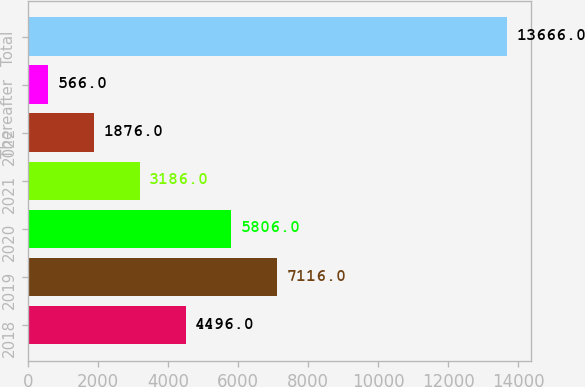Convert chart. <chart><loc_0><loc_0><loc_500><loc_500><bar_chart><fcel>2018<fcel>2019<fcel>2020<fcel>2021<fcel>2022<fcel>Thereafter<fcel>Total<nl><fcel>4496<fcel>7116<fcel>5806<fcel>3186<fcel>1876<fcel>566<fcel>13666<nl></chart> 